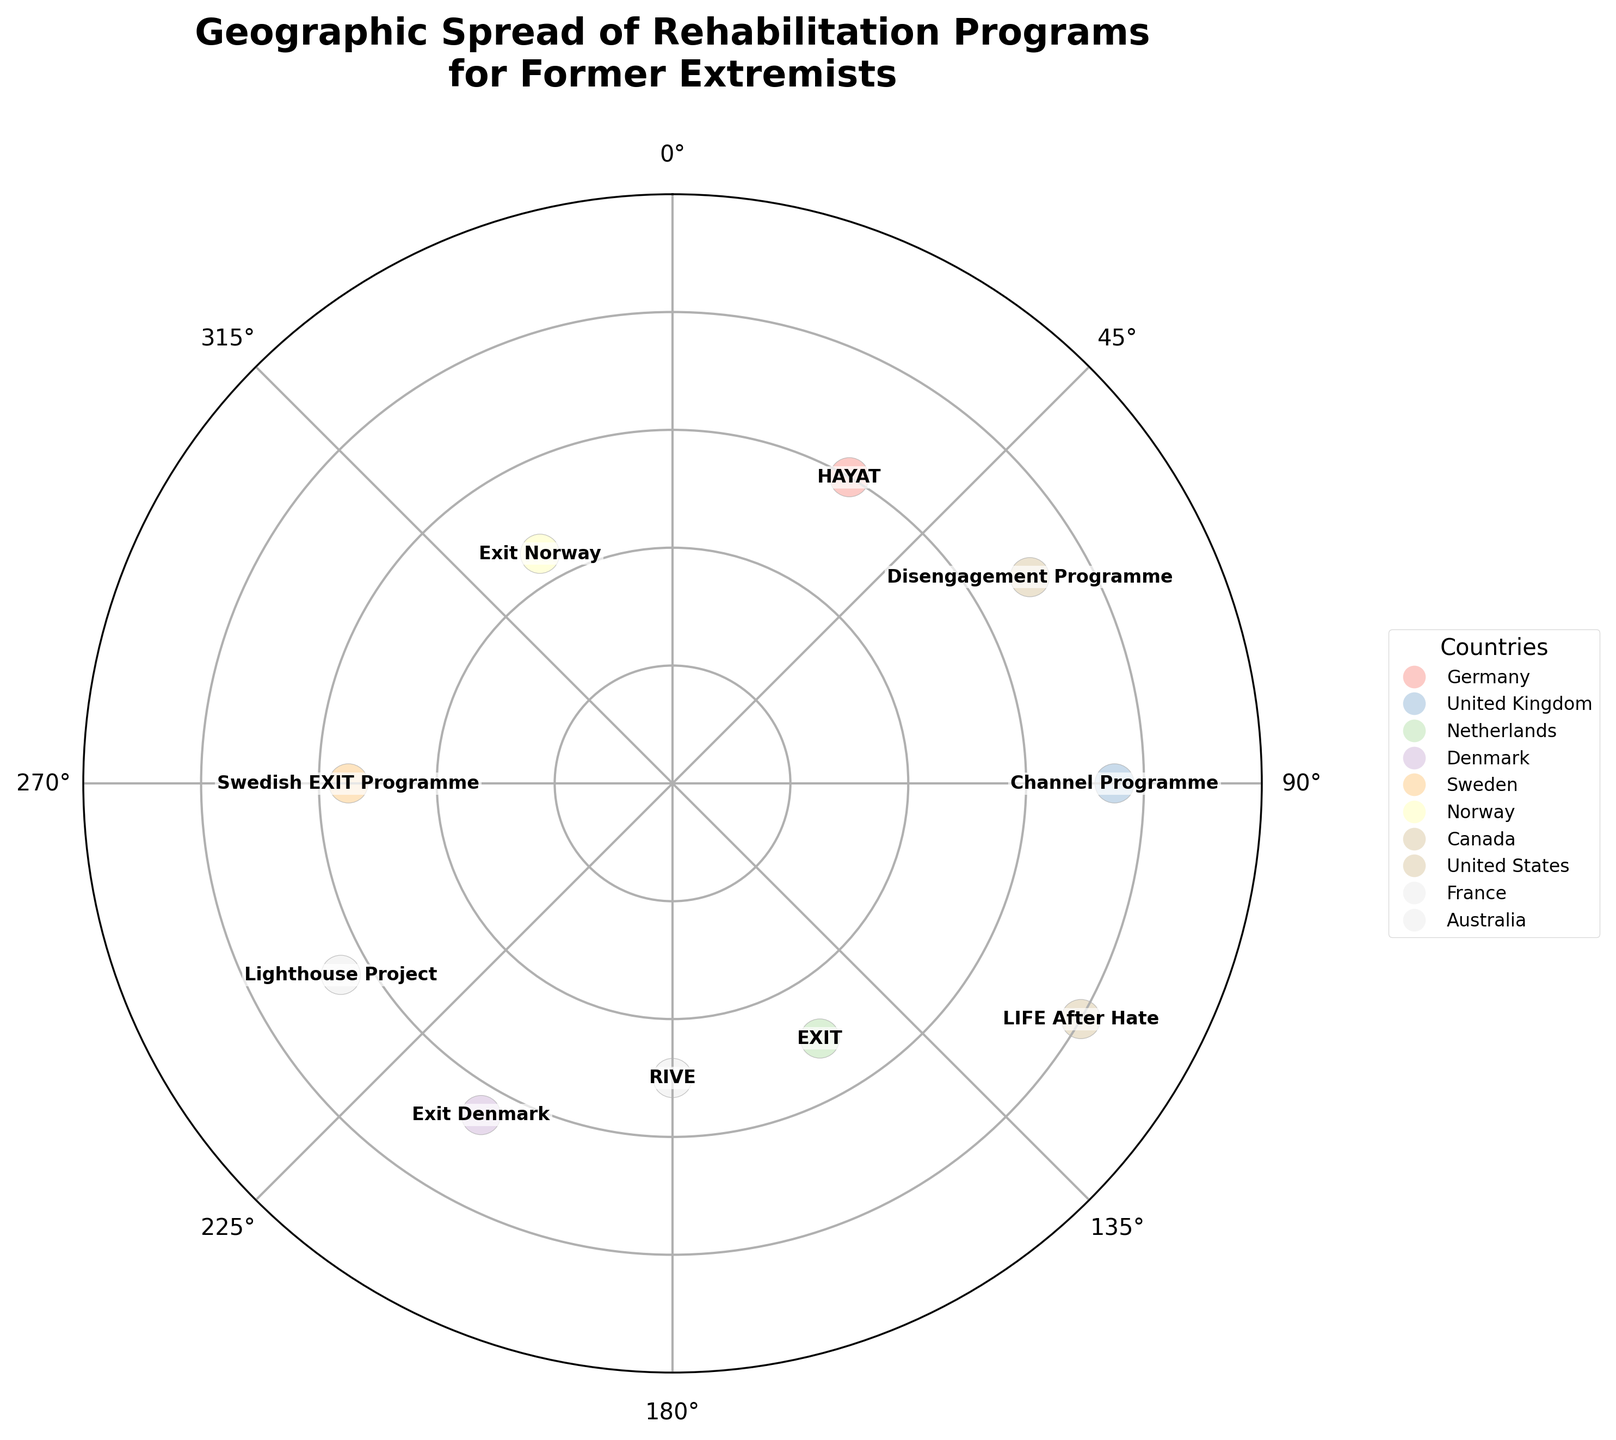How many countries are represented in the chart? By counting the number of distinct country names in the legend of the chart, we find that there are 10 countries.
Answer: 10 Which program has the highest y-magnitude value? By inspecting the plot, the program "LIFE After Hate" in the United States has the highest y-magnitude with a value of 80.
Answer: LIFE After Hate What is the average y-magnitude value of all the programs in the European countries? First, identify the European countries (Germany, United Kingdom, Netherlands, Denmark, Sweden, Norway, France) and their y-magnitude values (60, 75, 50, 65, 55, 45, 50). Summarize them: 60 + 75 + 50 + 65 + 55 + 45 + 50 = 400. There are 7 European programs, so the average is 400 / 7 = 57.14.
Answer: 57.14 Which program is located at the 270-degree mark? By examining the x-angles, the program "Swedish EXIT Programme" in Sweden is located at the 270-degree mark.
Answer: Swedish EXIT Programme Which program has both its y-magnitude and x-angle values greater than 60 and 180 respectively? Checking the values for each program, "LIFE After Hate" has a y-magnitude of 80 and x-angle of 120, and "Channel Programme" has a y-magnitude of 75 and x-angle of 90. Both exceed 60 in y-magnitude, but only "LIFE After Hate" meets the larger x-angle requirement.
Answer: None How is the y-magnitude of the "Channel Programme" compared to "Disengagement Programme"? The y-magnitude of the "Channel Programme" is 75, while the "Disengagement Programme" has a y-magnitude of 70. The y-magnitude of "Channel Programme" is higher.
Answer: Higher Which programs are directly opposite each other on the polar chart? Programs directly opposite would be 180 degrees apart. From observations, "Channel Programme" at 90 degrees and "EXIT" at 150 degrees, "Exit Denmark" at 210 degrees and "Swedish EXIT Programme" at 270 degrees are examples.
Answer: Channel Programme and EXIT What is the range of y-magnitude values represented in the chart? Identify the minimum and maximum y-magnitude values from the chart, which are 45 (Exit Norway) and 80 (LIFE After Hate). The range is 80 - 45 = 35.
Answer: 35 Which country is represented by the program at the 30-degree mark? By checking the x-angle values, the program "HAYAT" is located at the 30-degree mark, which is from Germany.
Answer: Germany 